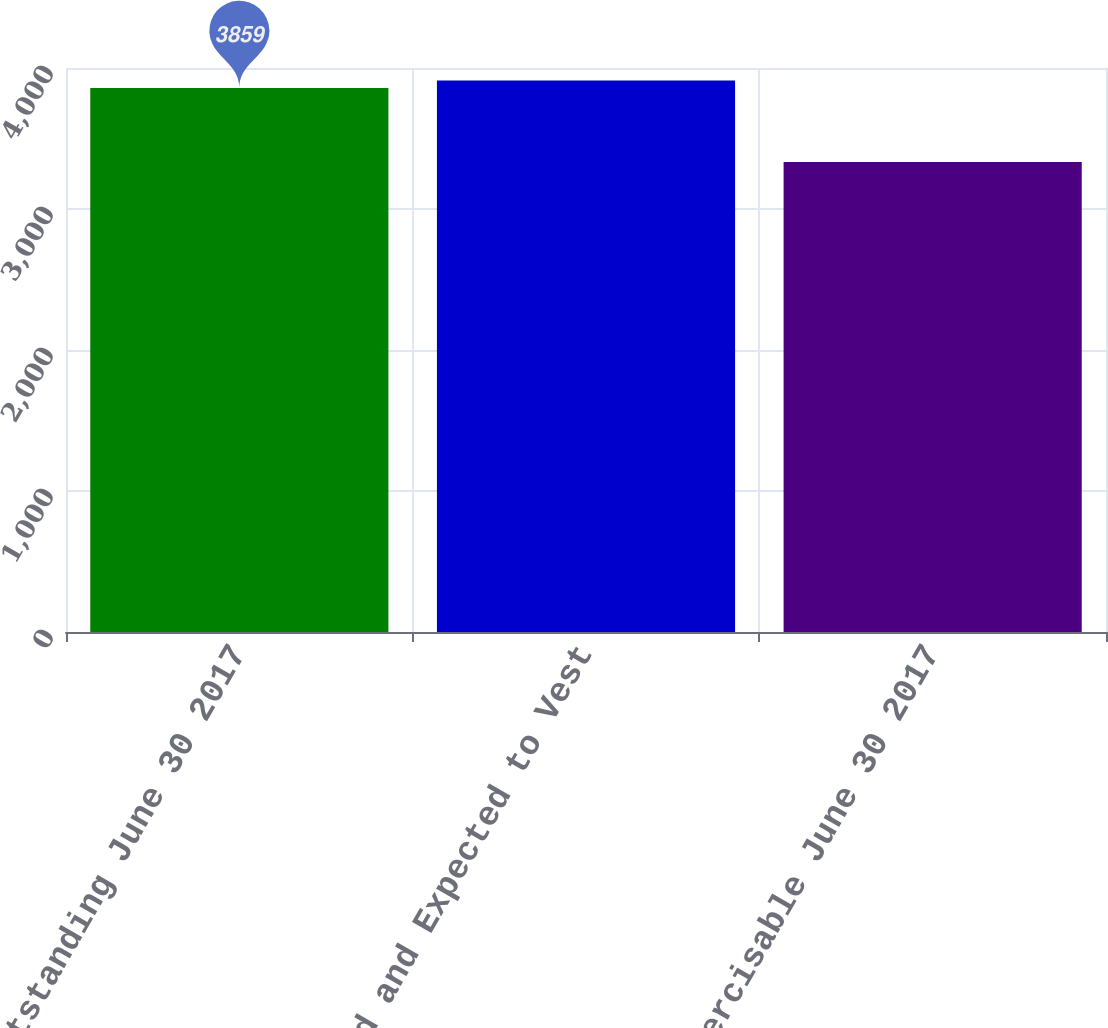Convert chart. <chart><loc_0><loc_0><loc_500><loc_500><bar_chart><fcel>Outstanding June 30 2017<fcel>Vested and Expected to Vest<fcel>Exercisable June 30 2017<nl><fcel>3859<fcel>3911.6<fcel>3333<nl></chart> 